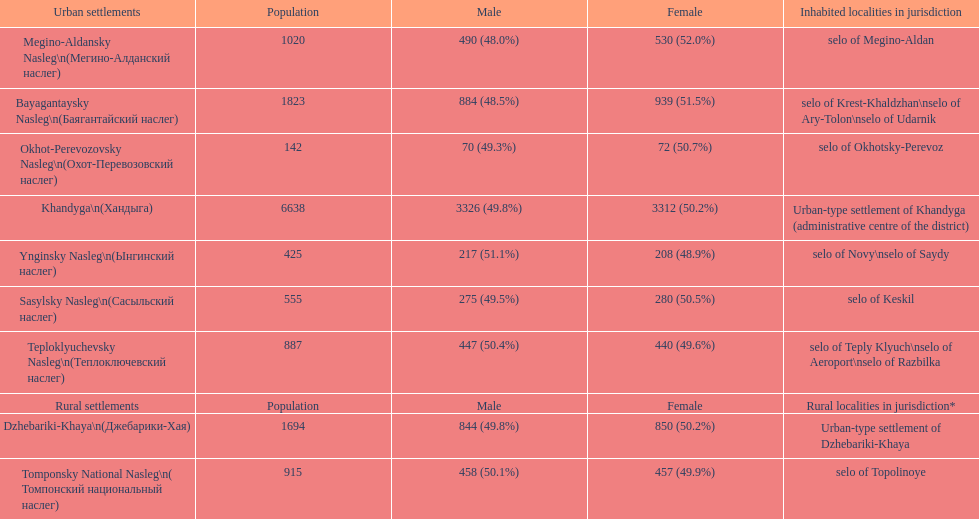What is the total population in dzhebariki-khaya? 1694. 